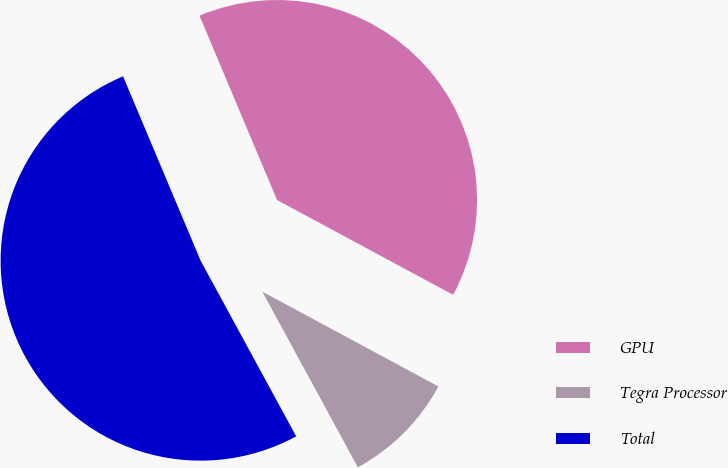Convert chart. <chart><loc_0><loc_0><loc_500><loc_500><pie_chart><fcel>GPU<fcel>Tegra Processor<fcel>Total<nl><fcel>39.2%<fcel>9.21%<fcel>51.59%<nl></chart> 